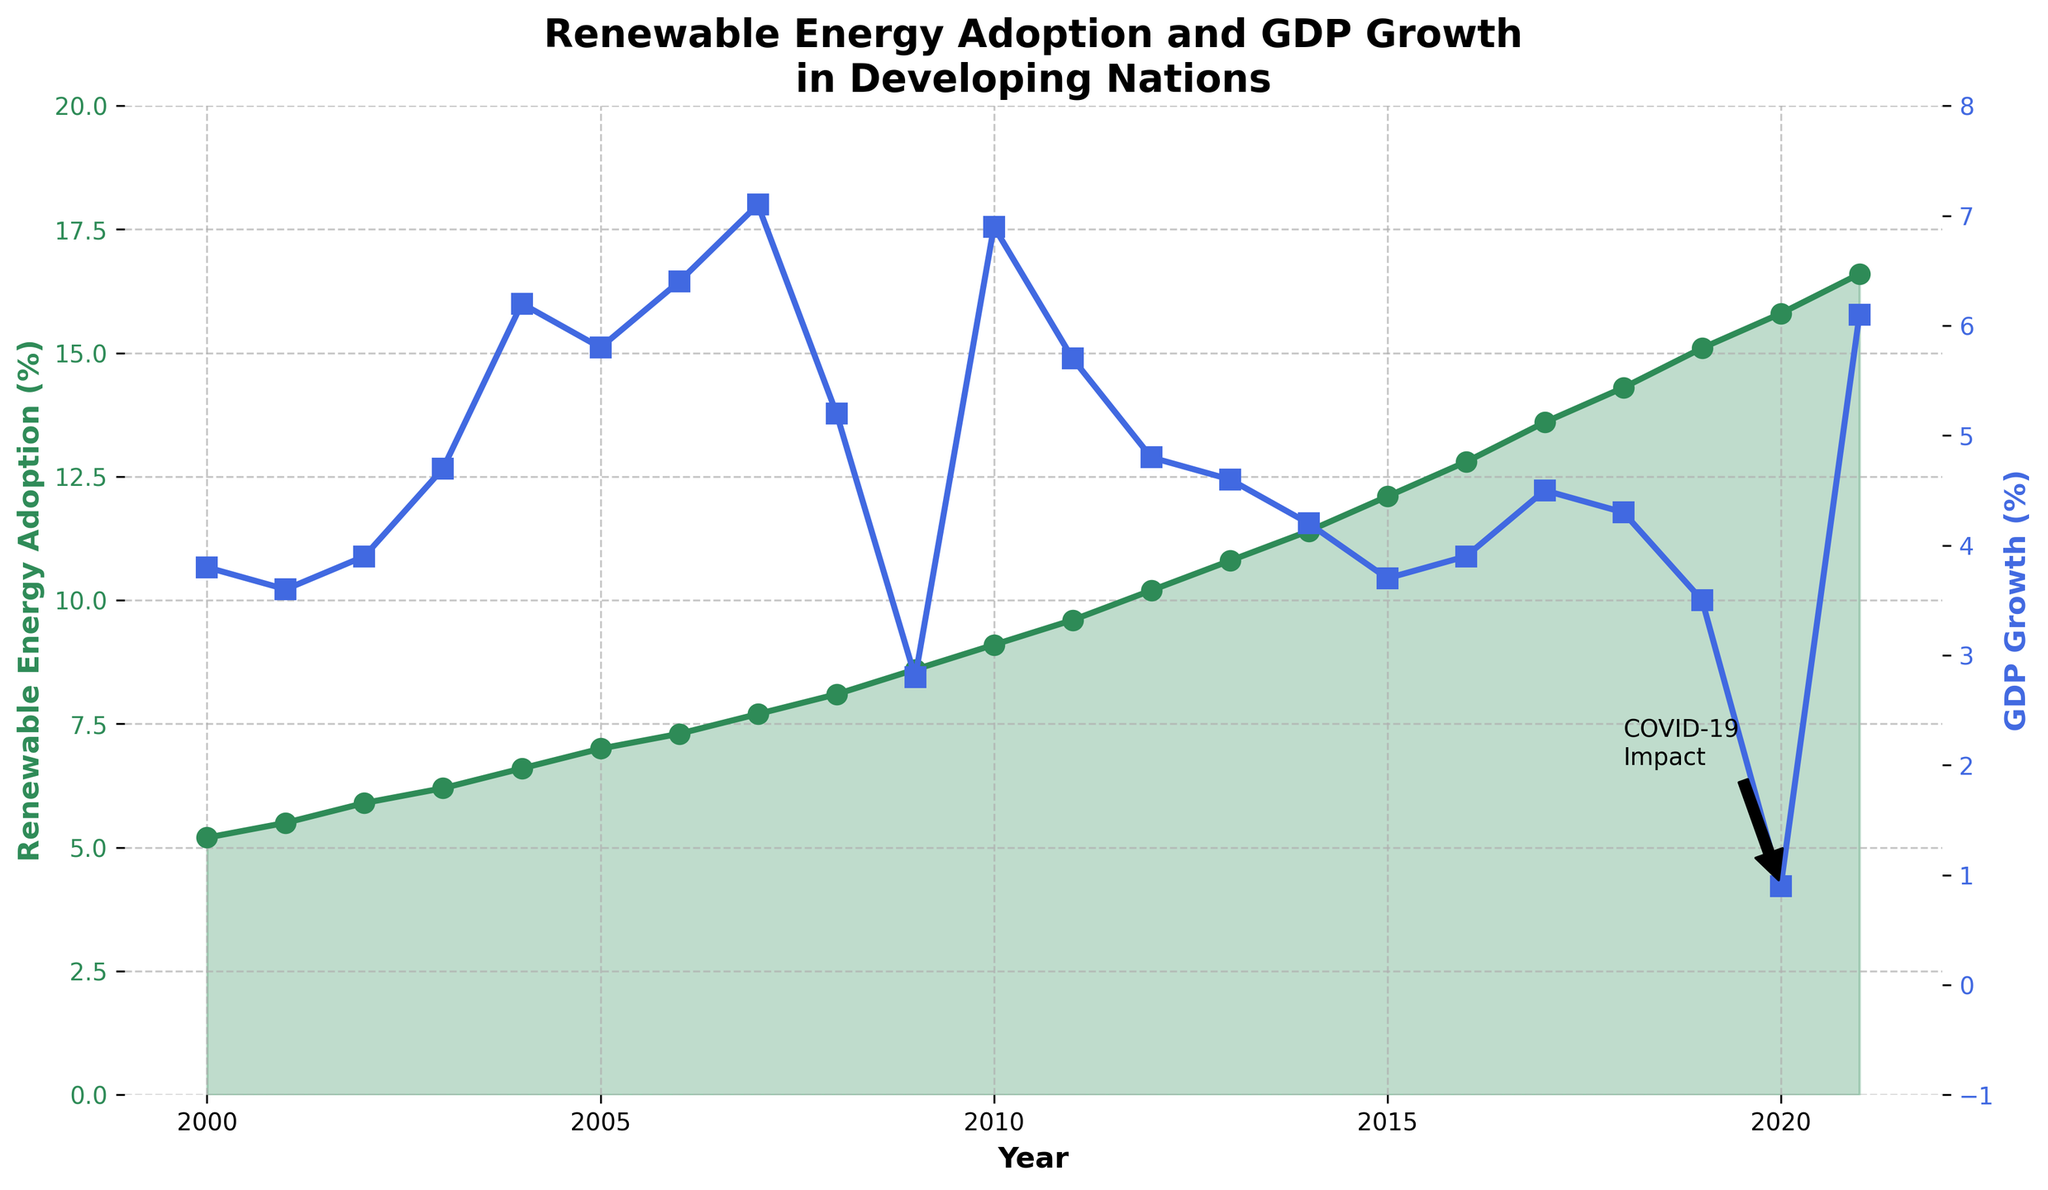What is the general trend of renewable energy adoption from 2000 to 2021? The line representing renewable energy adoption percentage is consistently increasing from 2000 to 2021, indicating a continuous growth trend.
Answer: Increasing How did the GDP growth percentage change between 2008 and 2009? The GDP growth percentage decreased from 5.2% in 2008 to 2.8% in 2009.
Answer: Decreased Which year experienced the highest renewable energy adoption percentage? By examining the peak of the green line, the year 2021 had the highest renewable energy adoption percentage at 16.6%.
Answer: 2021 In which year did GDP growth percentage reach its peak, and what was the value? The blue line reaches its highest point in 2004, where the GDP growth percentage was 6.2%.
Answer: 2004, 6.2% What visual attribute indicates the impact of COVID-19 on the chart? Annotations with text "COVID-19 Impact" and an arrow pointing to the year 2020 indicate the impact of COVID-19.
Answer: Annotation and arrow Compare the renewable energy adoption percentage in 2000 and 2020. Which year has a higher value and by how much? The renewable energy adoption percentage in 2000 was 5.2%, and in 2020 it was 15.8%. The difference is 15.8% - 5.2% = 10.6%.
Answer: 2020, 10.6% Identify a period where the GDP growth percentage shows a downward trend. What is the period and the change in percentage? Between 2008 and 2009, GDP growth percentage dropped from 5.2% to 2.8%.
Answer: 2008-2009, 2.4% How does the renewable energy adoption percentage visually compare to the GDP growth percentage in 2021? In 2021, the green line (renewable energy adoption) is higher at 16.6% compared to the blue line (GDP growth) at 6.1%.
Answer: Higher What is the visual difference between the renewable energy adoption and GDP growth percentages during the initial years of the data? In the early 2000s, the green line (renewable energy adoption) starts lower compared to the blue line (GDP growth), showing a slower initial growth in renewable energy adoption.
Answer: Renewable adoption starts lower Calculate the average GDP growth percentage from 2015 to 2020. The GDP growth percentages for the years 2015 to 2020 are 3.7, 3.9, 4.5, 4.3, 3.5, and 0.9. Sum them up: 3.7 + 3.9 + 4.5 + 4.3 + 3.5 + 0.9 = 20.8. The average over 6 years is 20.8 / 6 ≈ 3.47%.
Answer: 3.47% 